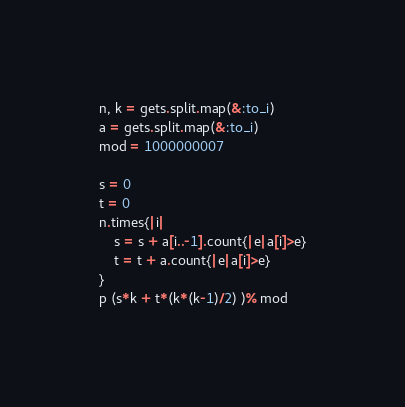<code> <loc_0><loc_0><loc_500><loc_500><_Ruby_>n, k = gets.split.map(&:to_i)
a = gets.split.map(&:to_i)
mod = 1000000007

s = 0
t = 0
n.times{|i|
    s = s + a[i..-1].count{|e|a[i]>e}
    t = t + a.count{|e|a[i]>e}
}
p (s*k + t*(k*(k-1)/2) )% mod</code> 